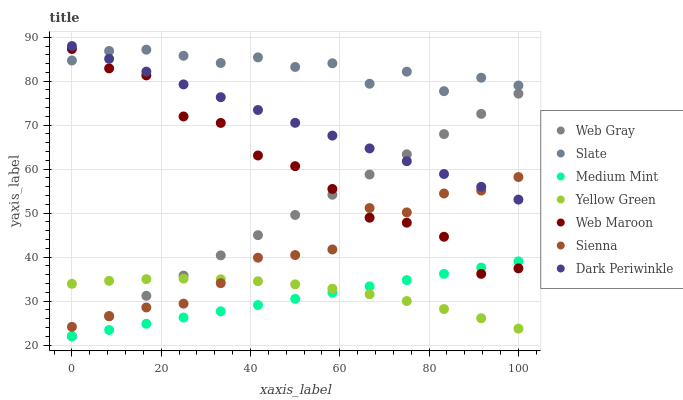Does Medium Mint have the minimum area under the curve?
Answer yes or no. Yes. Does Slate have the maximum area under the curve?
Answer yes or no. Yes. Does Web Gray have the minimum area under the curve?
Answer yes or no. No. Does Web Gray have the maximum area under the curve?
Answer yes or no. No. Is Dark Periwinkle the smoothest?
Answer yes or no. Yes. Is Web Maroon the roughest?
Answer yes or no. Yes. Is Web Gray the smoothest?
Answer yes or no. No. Is Web Gray the roughest?
Answer yes or no. No. Does Medium Mint have the lowest value?
Answer yes or no. Yes. Does Yellow Green have the lowest value?
Answer yes or no. No. Does Dark Periwinkle have the highest value?
Answer yes or no. Yes. Does Web Gray have the highest value?
Answer yes or no. No. Is Web Maroon less than Dark Periwinkle?
Answer yes or no. Yes. Is Slate greater than Medium Mint?
Answer yes or no. Yes. Does Web Gray intersect Dark Periwinkle?
Answer yes or no. Yes. Is Web Gray less than Dark Periwinkle?
Answer yes or no. No. Is Web Gray greater than Dark Periwinkle?
Answer yes or no. No. Does Web Maroon intersect Dark Periwinkle?
Answer yes or no. No. 